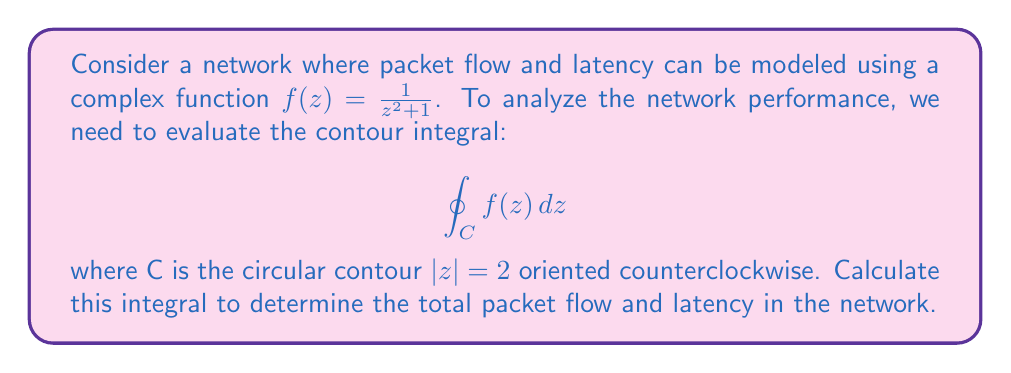Solve this math problem. To evaluate this contour integral, we'll use the Residue Theorem. The steps are as follows:

1) First, we need to find the singularities of $f(z)$ inside the contour C.
   The denominator of $f(z)$ is zero when $z^2 + 1 = 0$, or $z = \pm i$.
   Only $z = i$ is inside the contour $|z| = 2$.

2) Next, we calculate the residue at $z = i$:
   $$\text{Res}(f, i) = \lim_{z \to i} (z-i)f(z) = \lim_{z \to i} \frac{z-i}{z^2+1}$$
   
   Using L'Hôpital's rule:
   $$\text{Res}(f, i) = \lim_{z \to i} \frac{1}{2z} = \frac{1}{2i} = -\frac{i}{2}$$

3) Now we can apply the Residue Theorem:
   $$\oint_C f(z) dz = 2\pi i \sum \text{Res}(f, a_k)$$
   where $a_k$ are the singularities inside C.

4) In this case, we have only one singularity inside C:
   $$\oint_C f(z) dz = 2\pi i \cdot (-\frac{i}{2}) = \pi$$

This result represents the total packet flow and latency in the network. The real part (π) could represent the total flow, while the absence of an imaginary part suggests zero net latency over the entire network.
Answer: $\pi$ 